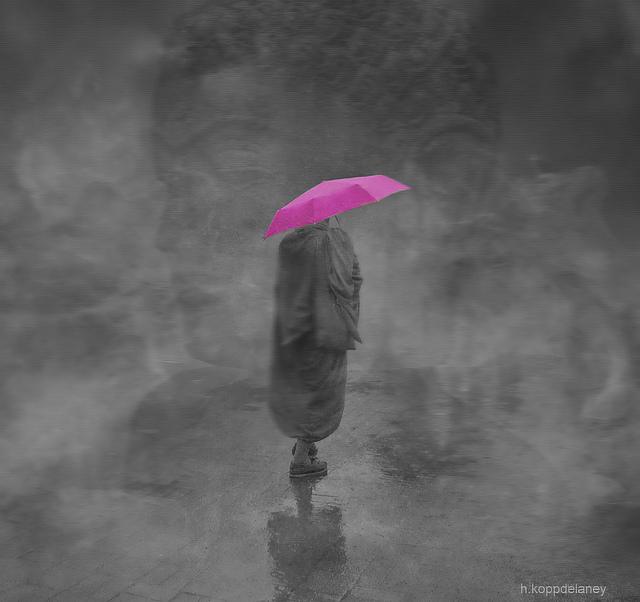What is the primary color in the photo?
Short answer required. Pink. How many images are superimposed in the picture?
Be succinct. 1. What color is the umbrella?
Short answer required. Pink. Why are numerous people wearing their hoods?
Be succinct. Rain. 